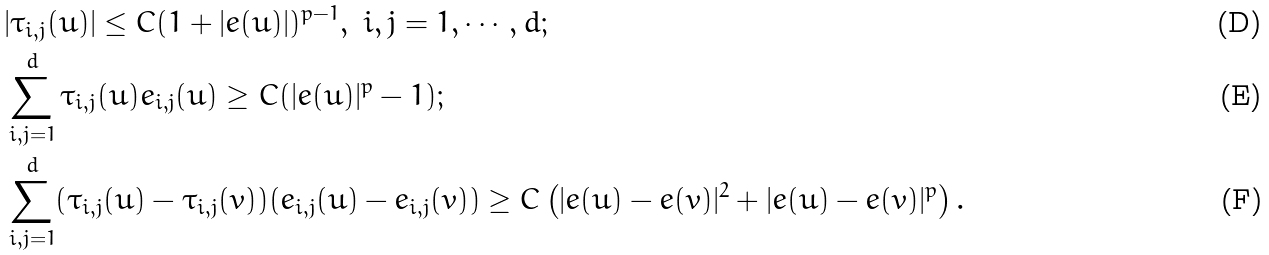Convert formula to latex. <formula><loc_0><loc_0><loc_500><loc_500>& | \tau _ { i , j } ( u ) | \leq C ( 1 + | e ( u ) | ) ^ { p - 1 } , \ i , j = 1 , \cdots , d ; \\ & \sum _ { i , j = 1 } ^ { d } \tau _ { i , j } ( u ) e _ { i , j } ( u ) \geq C ( | e ( u ) | ^ { p } - 1 ) ; \\ & \sum _ { i , j = 1 } ^ { d } ( \tau _ { i , j } ( u ) - \tau _ { i , j } ( v ) ) ( e _ { i , j } ( u ) - e _ { i , j } ( v ) ) \geq C \left ( | e ( u ) - e ( v ) | ^ { 2 } + | e ( u ) - e ( v ) | ^ { p } \right ) .</formula> 